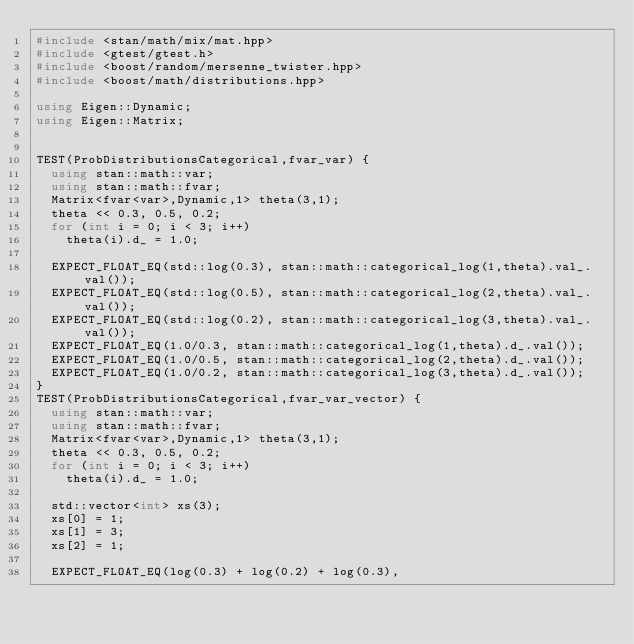<code> <loc_0><loc_0><loc_500><loc_500><_C++_>#include <stan/math/mix/mat.hpp>
#include <gtest/gtest.h>
#include <boost/random/mersenne_twister.hpp>
#include <boost/math/distributions.hpp>

using Eigen::Dynamic;
using Eigen::Matrix;


TEST(ProbDistributionsCategorical,fvar_var) {
  using stan::math::var;
  using stan::math::fvar;
  Matrix<fvar<var>,Dynamic,1> theta(3,1);
  theta << 0.3, 0.5, 0.2;
  for (int i = 0; i < 3; i++)
    theta(i).d_ = 1.0;

  EXPECT_FLOAT_EQ(std::log(0.3), stan::math::categorical_log(1,theta).val_.val());
  EXPECT_FLOAT_EQ(std::log(0.5), stan::math::categorical_log(2,theta).val_.val());
  EXPECT_FLOAT_EQ(std::log(0.2), stan::math::categorical_log(3,theta).val_.val());
  EXPECT_FLOAT_EQ(1.0/0.3, stan::math::categorical_log(1,theta).d_.val());
  EXPECT_FLOAT_EQ(1.0/0.5, stan::math::categorical_log(2,theta).d_.val());
  EXPECT_FLOAT_EQ(1.0/0.2, stan::math::categorical_log(3,theta).d_.val());
}
TEST(ProbDistributionsCategorical,fvar_var_vector) {
  using stan::math::var;
  using stan::math::fvar;
  Matrix<fvar<var>,Dynamic,1> theta(3,1);
  theta << 0.3, 0.5, 0.2;
  for (int i = 0; i < 3; i++)
    theta(i).d_ = 1.0;

  std::vector<int> xs(3);
  xs[0] = 1;
  xs[1] = 3;
  xs[2] = 1;
  
  EXPECT_FLOAT_EQ(log(0.3) + log(0.2) + log(0.3),</code> 